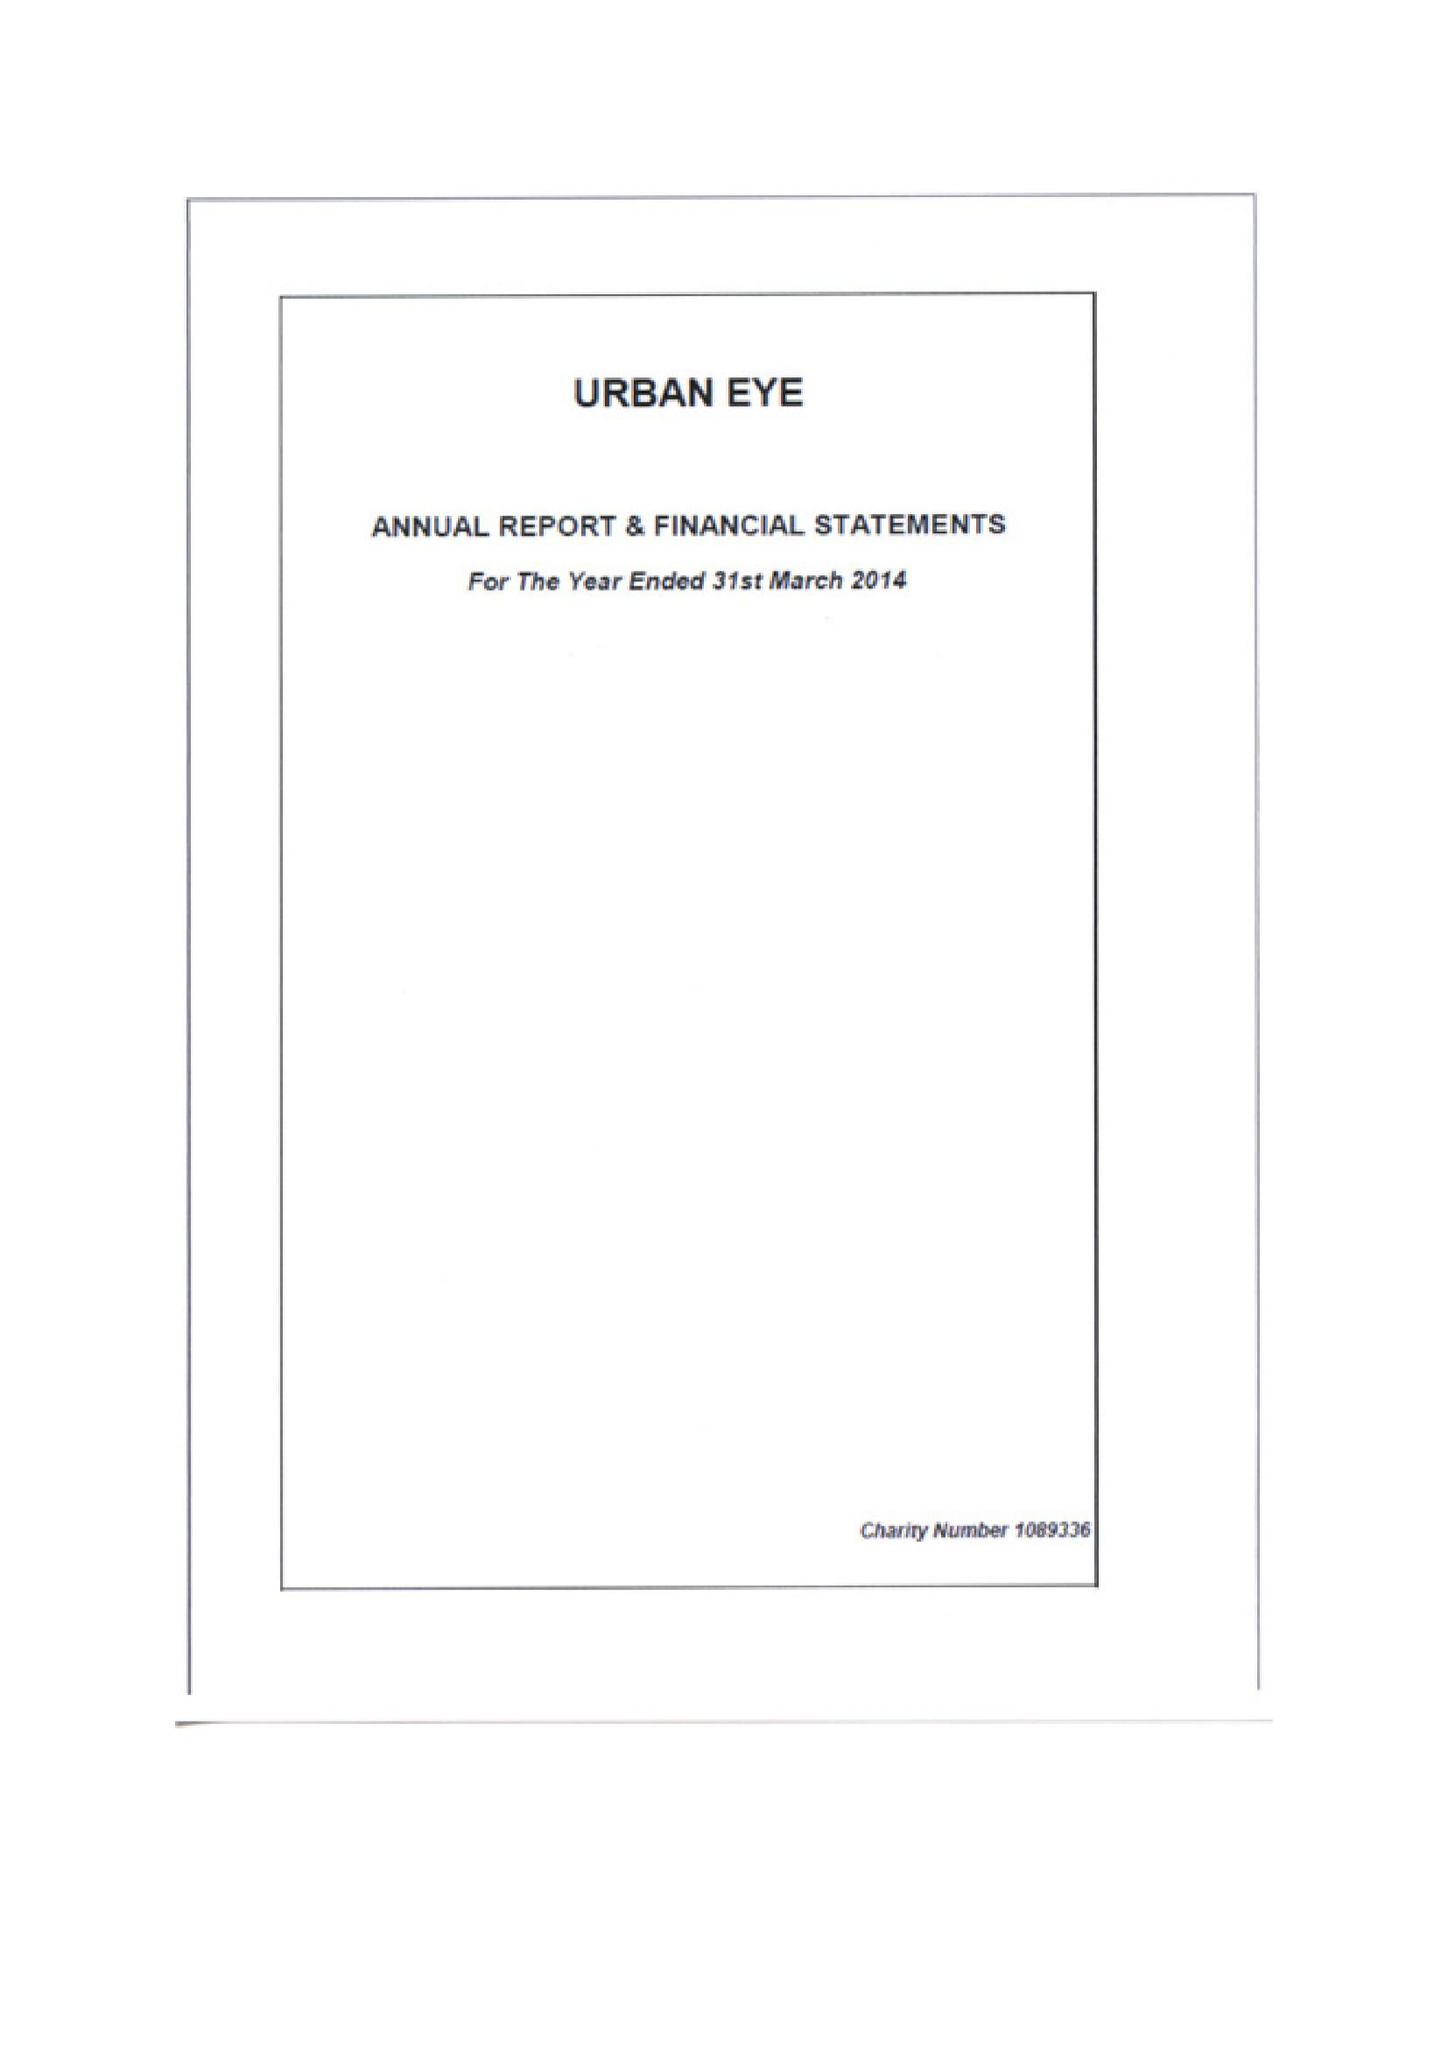What is the value for the spending_annually_in_british_pounds?
Answer the question using a single word or phrase. 140330.00 